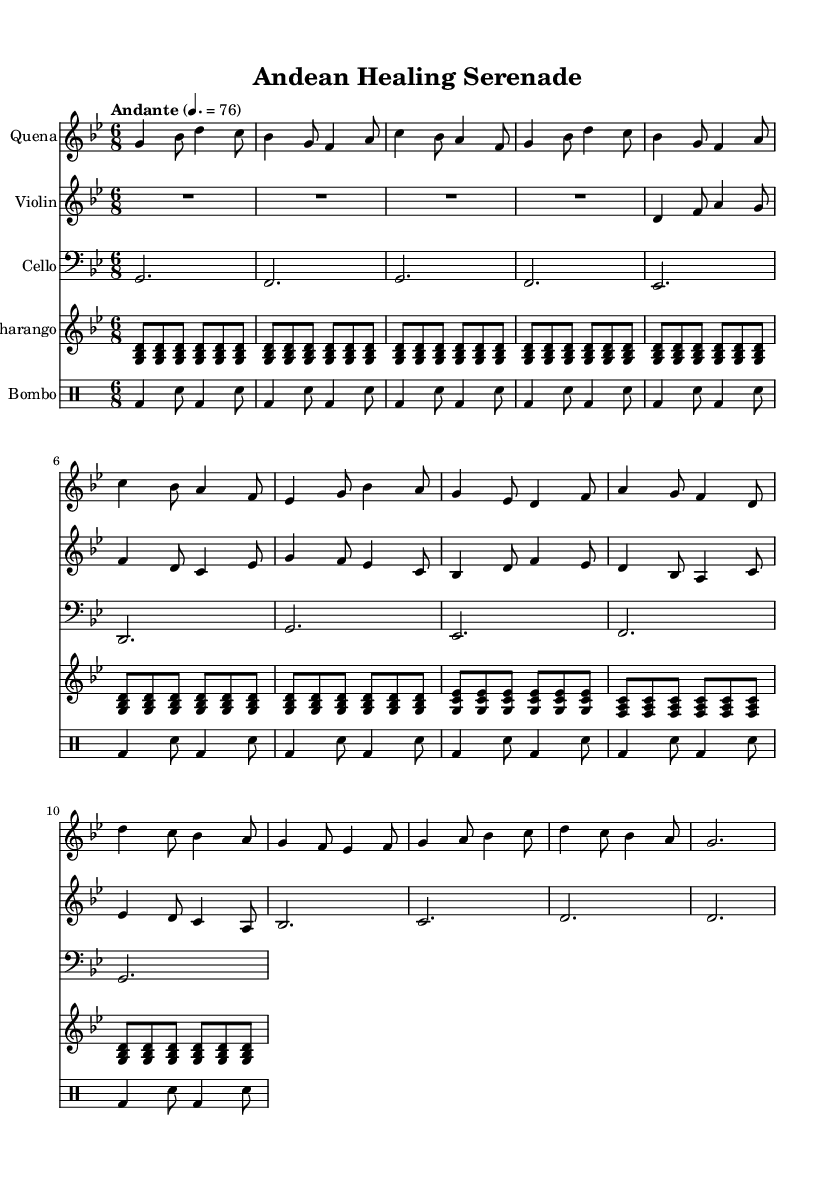What is the key signature of this music? The key signature is G minor, which has two flats (B flat and E flat). This can be identified by the key signature indicated at the beginning of the staff.
Answer: G minor What is the time signature of this piece? The time signature is 6/8, indicating that there are 6 eighth notes in each measure. This is shown at the beginning of the staff.
Answer: 6/8 What is the tempo marking for this piece? The tempo marking is "Andante," which suggests a moderate walking pace. This tempo is indicated above the staff with a metronome marking of 76 beats per minute.
Answer: Andante How many measures are in the quena part? The quena part contains 12 measures, which can be counted from the beginning to the end of the second line of music.
Answer: 12 What is the primary instrument used for melody in this piece? The primary instrument for melody is the quena, which plays the leading melodic lines throughout the piece, as indicated by the first staff labeled "Quena."
Answer: Quena Which instruments are playing polyrhythms in this music? The instruments playing polyrhythms are the bombo and charango. The bombo plays a steady beat while the charango adds rhythmic complexity with its own pattern, both contributing to the overall texture of the piece.
Answer: Bombo, Charango What cultural elements are reflected in this fusion piece? The piece reflects South American folk traditions through the use of indigenous instruments like the quena and charango, combined with classical elements represented by the violin and cello. The fusion of these styles conveys a deep emotional expression rooted in Andean music.
Answer: Indigenous instruments, classical elements 